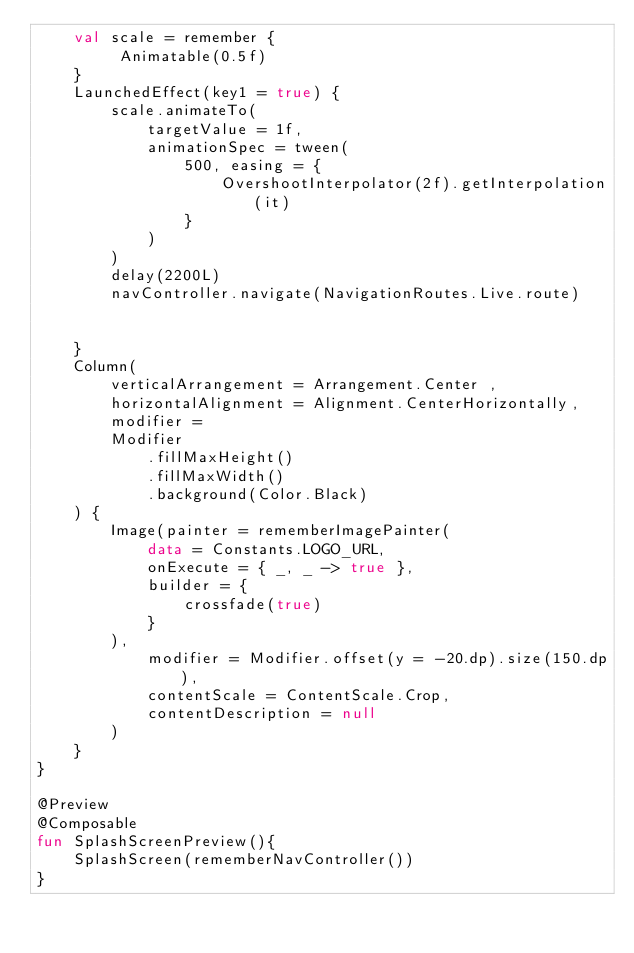<code> <loc_0><loc_0><loc_500><loc_500><_Kotlin_>    val scale = remember {
         Animatable(0.5f)
    }
    LaunchedEffect(key1 = true) {
        scale.animateTo(
            targetValue = 1f,
            animationSpec = tween(
                500, easing = {
                    OvershootInterpolator(2f).getInterpolation(it)
                }
            )
        )
        delay(2200L)
        navController.navigate(NavigationRoutes.Live.route)


    }
    Column(
        verticalArrangement = Arrangement.Center ,
        horizontalAlignment = Alignment.CenterHorizontally,
        modifier =
        Modifier
            .fillMaxHeight()
            .fillMaxWidth()
            .background(Color.Black)
    ) {
        Image(painter = rememberImagePainter(
            data = Constants.LOGO_URL,
            onExecute = { _, _ -> true },
            builder = {
                crossfade(true)
            }
        ),
            modifier = Modifier.offset(y = -20.dp).size(150.dp),
            contentScale = ContentScale.Crop,
            contentDescription = null
        )
    }
}

@Preview
@Composable
fun SplashScreenPreview(){
    SplashScreen(rememberNavController())
}</code> 